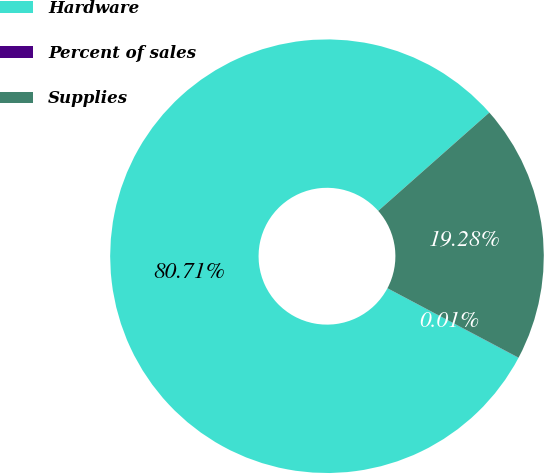Convert chart. <chart><loc_0><loc_0><loc_500><loc_500><pie_chart><fcel>Hardware<fcel>Percent of sales<fcel>Supplies<nl><fcel>80.71%<fcel>0.01%<fcel>19.28%<nl></chart> 